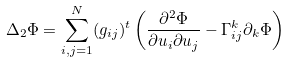<formula> <loc_0><loc_0><loc_500><loc_500>\Delta _ { 2 } \Phi = \sum ^ { N } _ { i , j = 1 } ( g _ { i j } ) ^ { t } \left ( \frac { \partial ^ { 2 } \Phi } { \partial u _ { i } \partial u _ { j } } - \Gamma ^ { k } _ { i j } \partial _ { k } \Phi \right )</formula> 